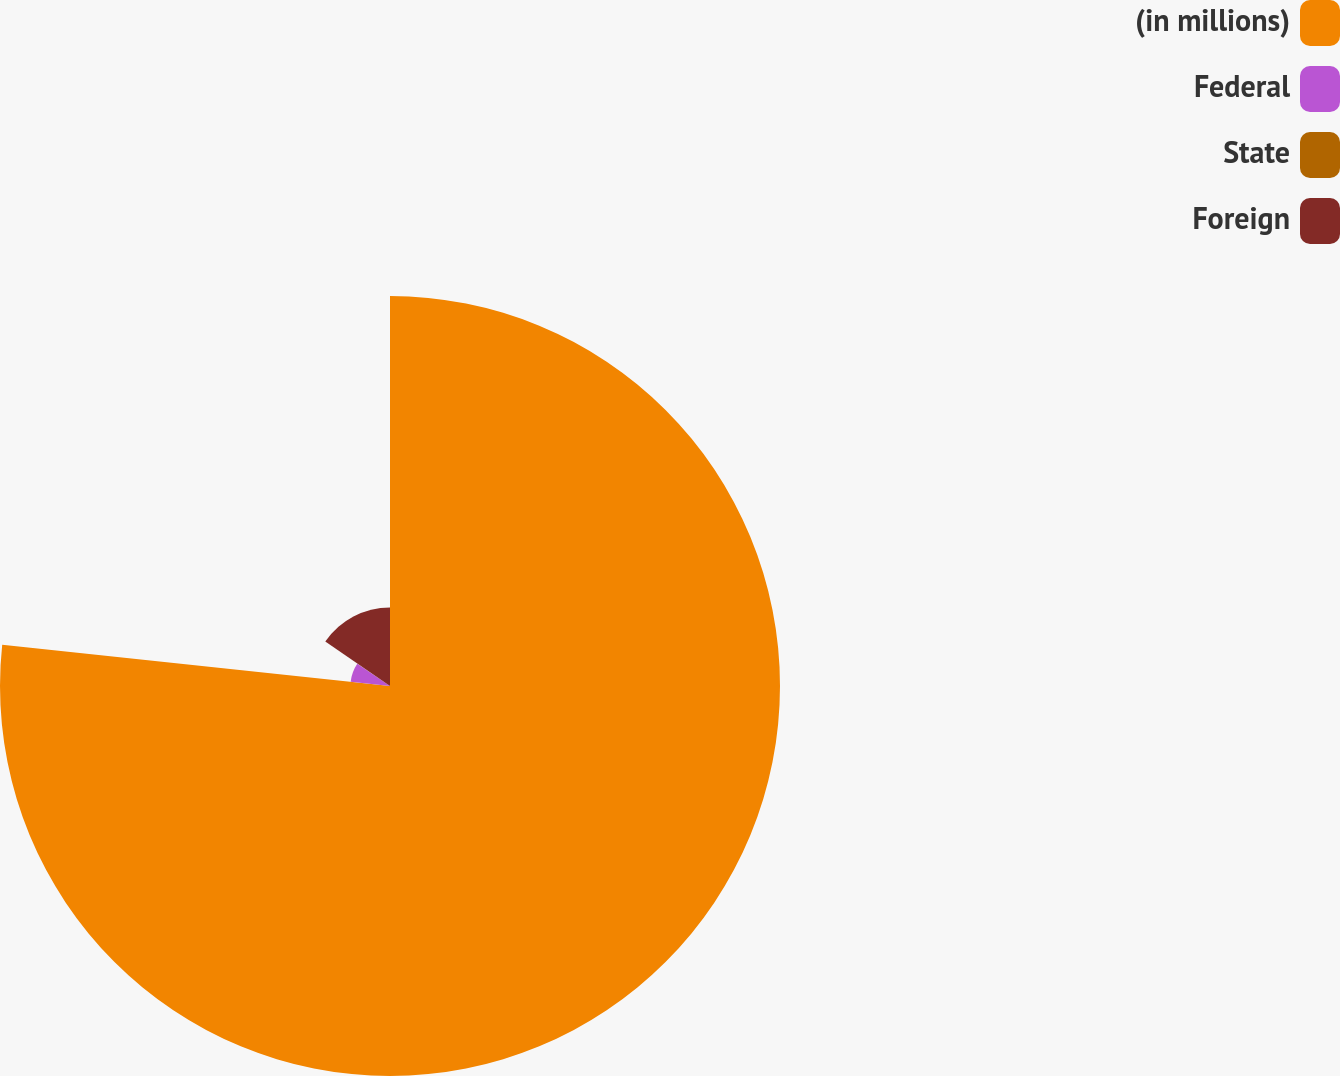Convert chart. <chart><loc_0><loc_0><loc_500><loc_500><pie_chart><fcel>(in millions)<fcel>Federal<fcel>State<fcel>Foreign<nl><fcel>76.69%<fcel>7.77%<fcel>0.11%<fcel>15.43%<nl></chart> 